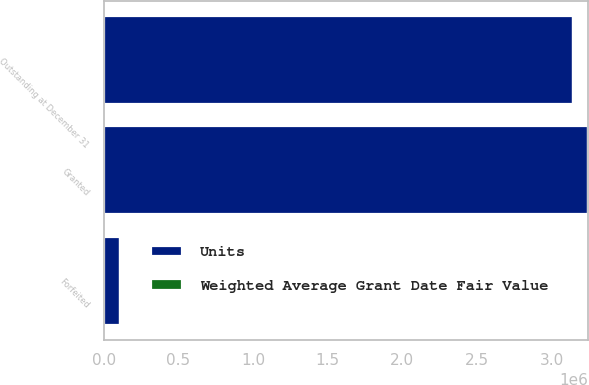Convert chart to OTSL. <chart><loc_0><loc_0><loc_500><loc_500><stacked_bar_chart><ecel><fcel>Granted<fcel>Forfeited<fcel>Outstanding at December 31<nl><fcel>Units<fcel>3.24632e+06<fcel>106200<fcel>3.14012e+06<nl><fcel>Weighted Average Grant Date Fair Value<fcel>25.45<fcel>25.54<fcel>25.44<nl></chart> 